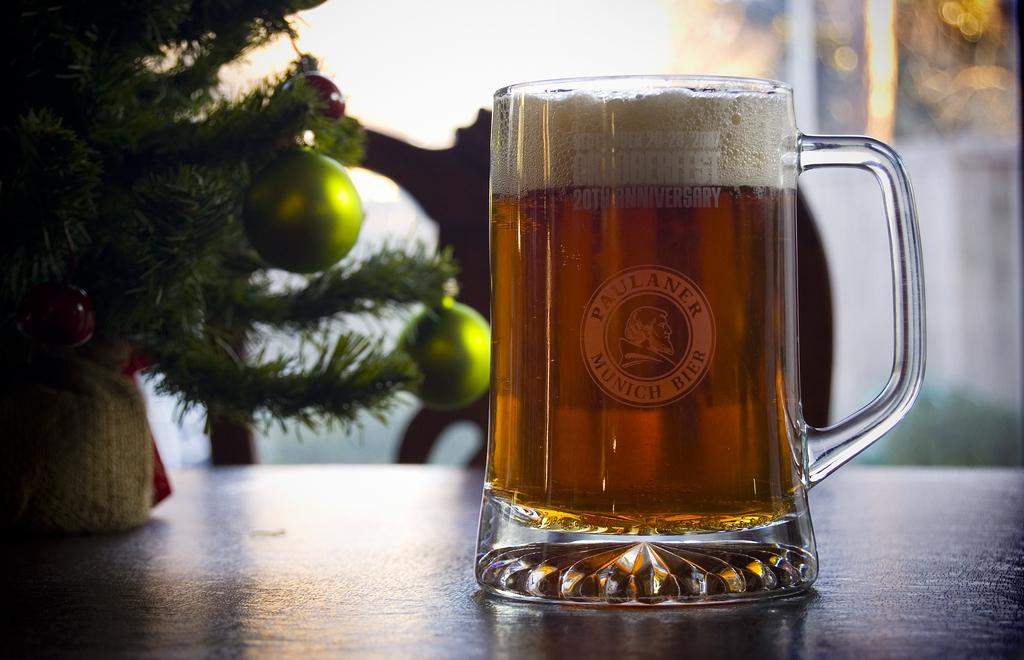What is the main object in the image? There is a wine glass in the image. Where is the wine glass located? The wine glass is placed on a table. What other object is near the wine glass? There is a plant in the image, and it is near the wine glass. What piece of furniture is beside the table? There is a chair in the image, and it is placed beside the table. How would you describe the background of the image? The background of the image is blurred. What organization is responsible for the arrangement of the wine glass and plant in the image? There is no organization mentioned or implied in the image, and the arrangement of the wine glass and plant is not attributed to any specific entity. 